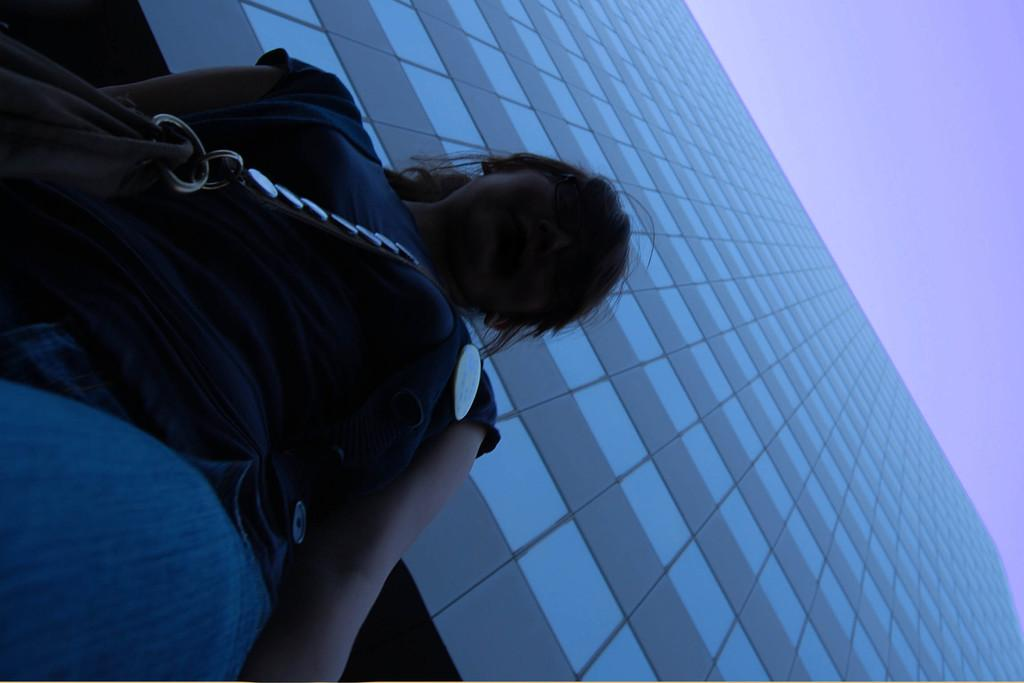What is the main subject of the image? There is a woman standing in the image. What can be seen in the background of the image? There is a building and the sky visible in the background of the image. What type of horn can be heard in the image? There is no horn or any sound present in the image, as it is a still photograph. 